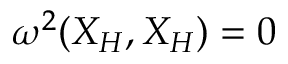<formula> <loc_0><loc_0><loc_500><loc_500>\begin{array} { r } { \omega ^ { 2 } ( X _ { H } , X _ { H } ) = 0 } \end{array}</formula> 